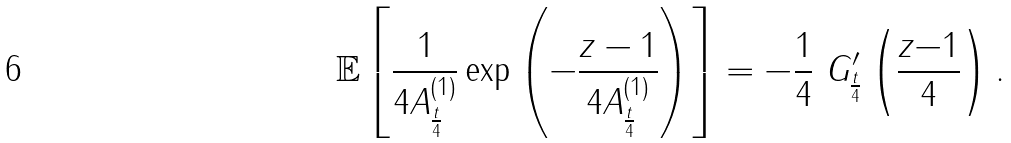<formula> <loc_0><loc_0><loc_500><loc_500>\mathbb { E } \left [ \frac { 1 } { 4 A _ { \frac { t } { 4 } } ^ { ( 1 ) } } \exp \left ( - \frac { z - 1 } { 4 A _ { \frac { t } { 4 } } ^ { ( 1 ) } } \right ) \right ] = - \frac { 1 } { 4 } \ G ^ { \prime } _ { \frac { t } { 4 } } \left ( \frac { z { - 1 } } { 4 } \right ) .</formula> 